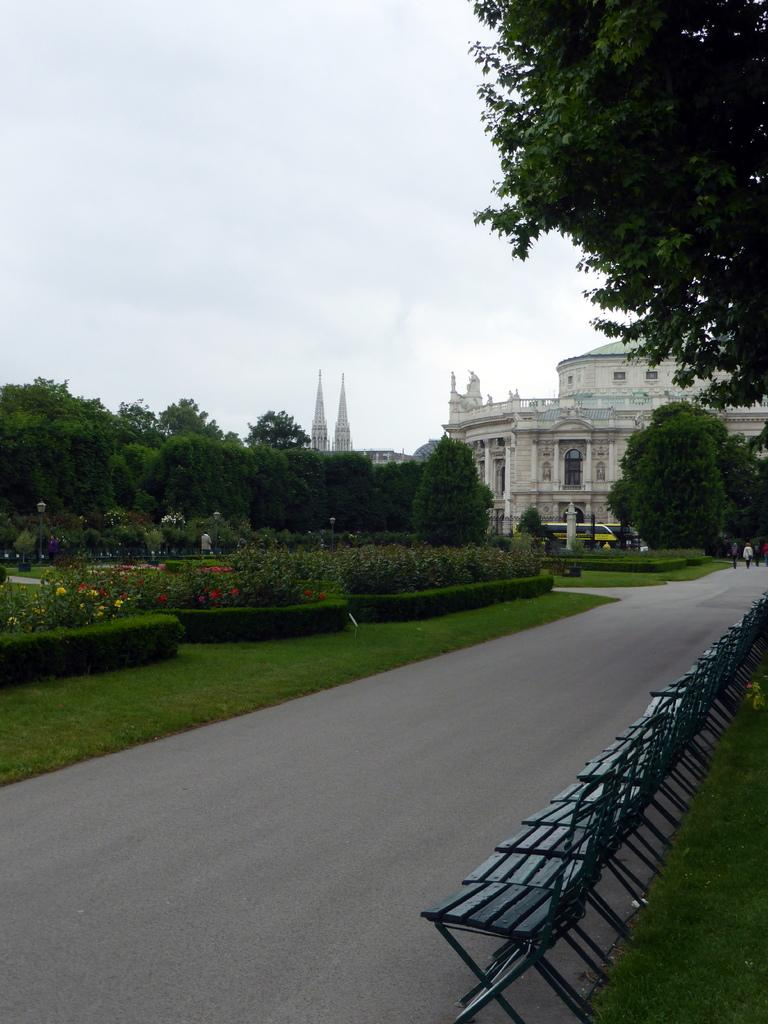What type of structure is present in the image? There is a building in the image. What feature can be seen on the building? The building has windows. What type of vegetation is visible in the image? There are trees and flowers in the image. What objects are placed on the road in the image? There are chairs on the road in the image. What is visible in the background of the image? The sky is visible in the image. What type of toy can be seen floating in the sky in the image? There is no toy present in the image, and nothing is floating in the sky. 